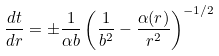<formula> <loc_0><loc_0><loc_500><loc_500>\frac { d t } { d r } = \pm \frac { 1 } { \alpha b } \left ( \frac { 1 } { b ^ { 2 } } - \frac { \alpha ( r ) } { r ^ { 2 } } \right ) ^ { - 1 / 2 }</formula> 